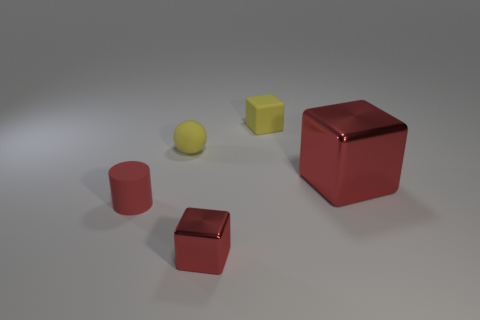Can you describe the textures of the different objects in the image? Certainly. The larger cube appears to have a highly reflective surface, perhaps indicative of a polished metal. The smaller cube and cylinder share a matte finish, suggesting a non-reflective, possibly painted or plastic material. The spherical objects have a slightly textured look that could be indicative of a rubbery material. 